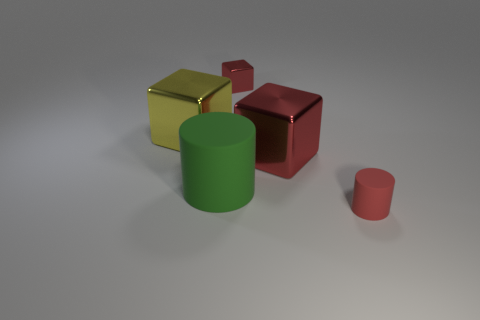Subtract all large red metallic cubes. How many cubes are left? 2 Subtract all cubes. How many objects are left? 2 Subtract all green cylinders. How many cylinders are left? 1 Add 1 small metal objects. How many objects exist? 6 Subtract 2 blocks. How many blocks are left? 1 Add 4 big rubber things. How many big rubber things exist? 5 Subtract 0 brown cubes. How many objects are left? 5 Subtract all green cylinders. Subtract all gray spheres. How many cylinders are left? 1 Subtract all blue spheres. How many cyan cylinders are left? 0 Subtract all large green cubes. Subtract all red cubes. How many objects are left? 3 